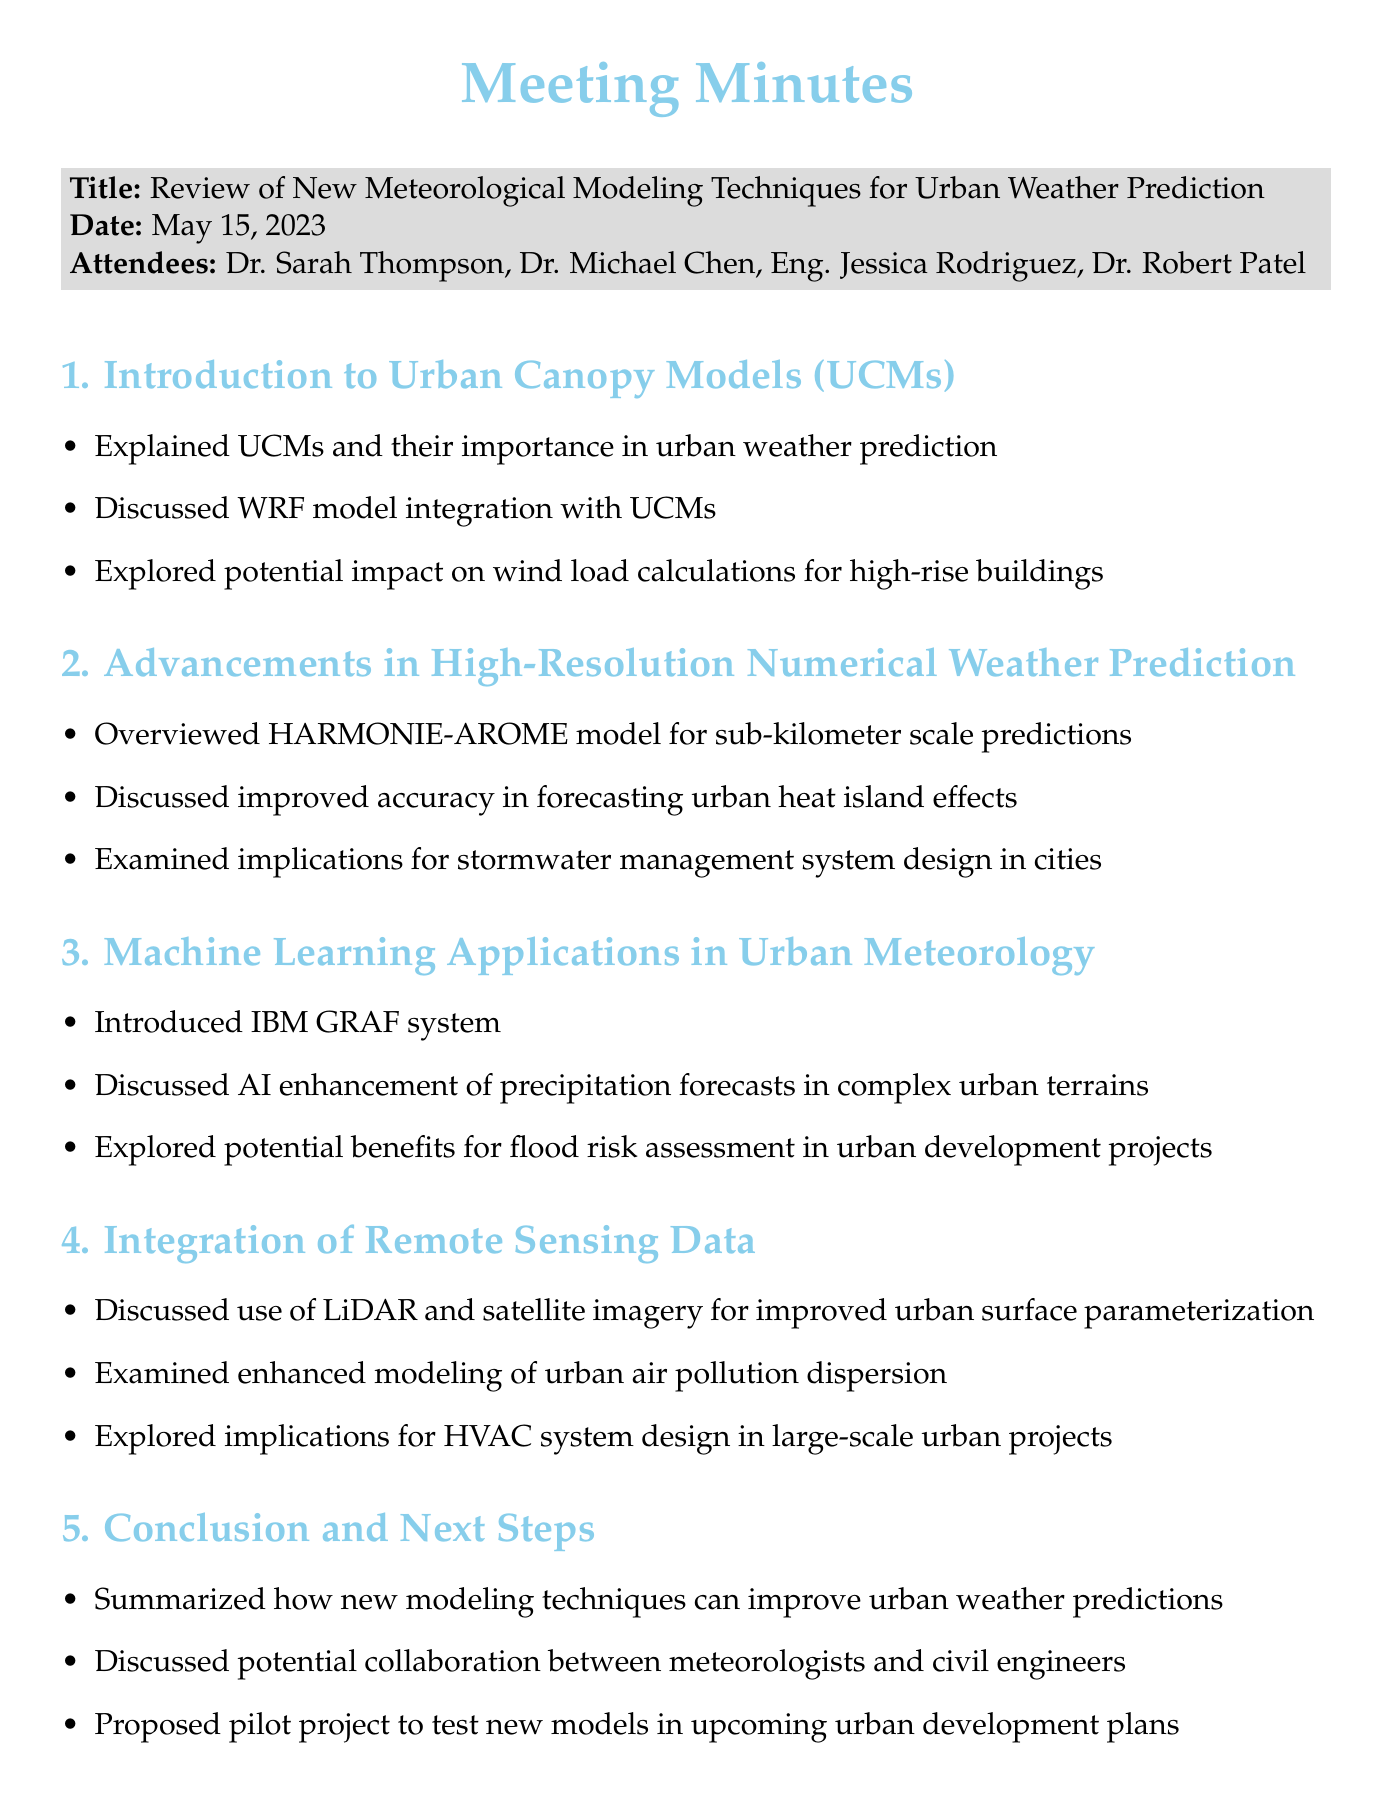What was the date of the meeting? The date of the meeting is explicitly mentioned in the document, which is May 15, 2023.
Answer: May 15, 2023 Who is the Lead Meteorologist? The document lists Dr. Sarah Thompson as the Lead Meteorologist among the attendees.
Answer: Dr. Sarah Thompson What model was discussed for sub-kilometer scale predictions? The specific model discussed for sub-kilometer scale predictions is outlined in the second agenda item, which is the HARMONIE-AROME model.
Answer: HARMONIE-AROME What is the purpose of the proposed pilot project? The pilot project is proposed to test new models in upcoming urban development plans, as detailed in the conclusion section.
Answer: Test new models What technology was mentioned for urban air pollution dispersion modeling? The use of LiDAR and satellite imagery is mentioned for improved urban air pollution dispersion modeling in the document.
Answer: LiDAR and satellite imagery How many attendees were present at the meeting? The document lists four attendees at the meeting.
Answer: Four What implication was discussed concerning stormwater management systems? The document states that improved accuracy from the HARMONIE-AROME model has implications for stormwater management systems design in cities.
Answer: Stormwater management system design Which organization's system enhances precipitation forecasts? The IBM GRAF system is introduced in the document as enhancing precipitation forecasts in complex urban terrains.
Answer: IBM GRAF What is one potential benefit of machine learning applications in urban meteorology? The document discusses potential benefits for flood risk assessment in urban development projects, which is a key application of machine learning in this context.
Answer: Flood risk assessment 